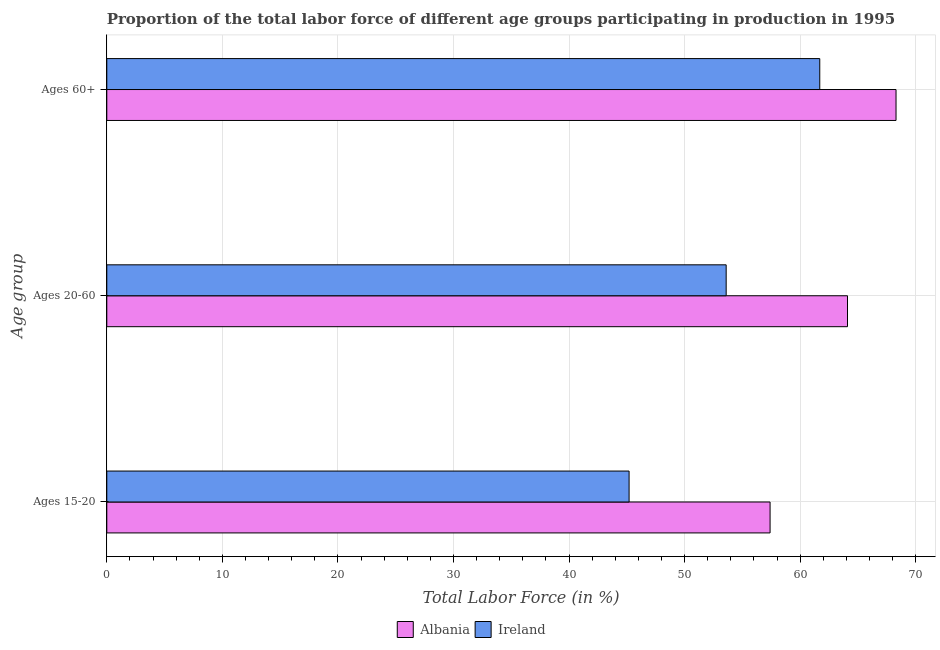How many different coloured bars are there?
Ensure brevity in your answer.  2. How many groups of bars are there?
Ensure brevity in your answer.  3. How many bars are there on the 2nd tick from the top?
Ensure brevity in your answer.  2. What is the label of the 1st group of bars from the top?
Keep it short and to the point. Ages 60+. What is the percentage of labor force above age 60 in Ireland?
Ensure brevity in your answer.  61.7. Across all countries, what is the maximum percentage of labor force within the age group 15-20?
Provide a short and direct response. 57.4. Across all countries, what is the minimum percentage of labor force within the age group 20-60?
Offer a terse response. 53.6. In which country was the percentage of labor force within the age group 15-20 maximum?
Give a very brief answer. Albania. In which country was the percentage of labor force within the age group 20-60 minimum?
Ensure brevity in your answer.  Ireland. What is the total percentage of labor force above age 60 in the graph?
Your answer should be very brief. 130. What is the difference between the percentage of labor force within the age group 15-20 in Ireland and that in Albania?
Ensure brevity in your answer.  -12.2. What is the difference between the percentage of labor force within the age group 15-20 in Ireland and the percentage of labor force above age 60 in Albania?
Ensure brevity in your answer.  -23.1. What is the average percentage of labor force within the age group 15-20 per country?
Your answer should be compact. 51.3. What is the difference between the percentage of labor force within the age group 15-20 and percentage of labor force within the age group 20-60 in Ireland?
Your response must be concise. -8.4. What is the ratio of the percentage of labor force within the age group 20-60 in Albania to that in Ireland?
Offer a very short reply. 1.2. What is the difference between the highest and the second highest percentage of labor force above age 60?
Ensure brevity in your answer.  6.6. What is the difference between the highest and the lowest percentage of labor force above age 60?
Offer a terse response. 6.6. In how many countries, is the percentage of labor force within the age group 20-60 greater than the average percentage of labor force within the age group 20-60 taken over all countries?
Provide a succinct answer. 1. Is the sum of the percentage of labor force within the age group 20-60 in Albania and Ireland greater than the maximum percentage of labor force above age 60 across all countries?
Offer a terse response. Yes. What does the 2nd bar from the top in Ages 15-20 represents?
Offer a terse response. Albania. What does the 1st bar from the bottom in Ages 15-20 represents?
Your answer should be very brief. Albania. How many bars are there?
Your answer should be compact. 6. Are all the bars in the graph horizontal?
Ensure brevity in your answer.  Yes. How many countries are there in the graph?
Ensure brevity in your answer.  2. What is the difference between two consecutive major ticks on the X-axis?
Give a very brief answer. 10. Are the values on the major ticks of X-axis written in scientific E-notation?
Offer a terse response. No. Does the graph contain any zero values?
Offer a terse response. No. Where does the legend appear in the graph?
Ensure brevity in your answer.  Bottom center. How many legend labels are there?
Make the answer very short. 2. How are the legend labels stacked?
Your response must be concise. Horizontal. What is the title of the graph?
Keep it short and to the point. Proportion of the total labor force of different age groups participating in production in 1995. Does "Algeria" appear as one of the legend labels in the graph?
Your response must be concise. No. What is the label or title of the X-axis?
Keep it short and to the point. Total Labor Force (in %). What is the label or title of the Y-axis?
Your answer should be compact. Age group. What is the Total Labor Force (in %) of Albania in Ages 15-20?
Provide a succinct answer. 57.4. What is the Total Labor Force (in %) of Ireland in Ages 15-20?
Make the answer very short. 45.2. What is the Total Labor Force (in %) of Albania in Ages 20-60?
Keep it short and to the point. 64.1. What is the Total Labor Force (in %) in Ireland in Ages 20-60?
Your answer should be compact. 53.6. What is the Total Labor Force (in %) of Albania in Ages 60+?
Keep it short and to the point. 68.3. What is the Total Labor Force (in %) of Ireland in Ages 60+?
Keep it short and to the point. 61.7. Across all Age group, what is the maximum Total Labor Force (in %) in Albania?
Your answer should be compact. 68.3. Across all Age group, what is the maximum Total Labor Force (in %) in Ireland?
Your answer should be compact. 61.7. Across all Age group, what is the minimum Total Labor Force (in %) in Albania?
Give a very brief answer. 57.4. Across all Age group, what is the minimum Total Labor Force (in %) of Ireland?
Provide a succinct answer. 45.2. What is the total Total Labor Force (in %) in Albania in the graph?
Offer a very short reply. 189.8. What is the total Total Labor Force (in %) in Ireland in the graph?
Provide a short and direct response. 160.5. What is the difference between the Total Labor Force (in %) in Ireland in Ages 15-20 and that in Ages 20-60?
Ensure brevity in your answer.  -8.4. What is the difference between the Total Labor Force (in %) in Ireland in Ages 15-20 and that in Ages 60+?
Provide a succinct answer. -16.5. What is the difference between the Total Labor Force (in %) of Albania in Ages 20-60 and that in Ages 60+?
Provide a succinct answer. -4.2. What is the difference between the Total Labor Force (in %) of Albania in Ages 15-20 and the Total Labor Force (in %) of Ireland in Ages 20-60?
Give a very brief answer. 3.8. What is the average Total Labor Force (in %) of Albania per Age group?
Your response must be concise. 63.27. What is the average Total Labor Force (in %) of Ireland per Age group?
Offer a very short reply. 53.5. What is the difference between the Total Labor Force (in %) of Albania and Total Labor Force (in %) of Ireland in Ages 60+?
Offer a terse response. 6.6. What is the ratio of the Total Labor Force (in %) in Albania in Ages 15-20 to that in Ages 20-60?
Your answer should be compact. 0.9. What is the ratio of the Total Labor Force (in %) in Ireland in Ages 15-20 to that in Ages 20-60?
Keep it short and to the point. 0.84. What is the ratio of the Total Labor Force (in %) of Albania in Ages 15-20 to that in Ages 60+?
Ensure brevity in your answer.  0.84. What is the ratio of the Total Labor Force (in %) of Ireland in Ages 15-20 to that in Ages 60+?
Ensure brevity in your answer.  0.73. What is the ratio of the Total Labor Force (in %) in Albania in Ages 20-60 to that in Ages 60+?
Your answer should be very brief. 0.94. What is the ratio of the Total Labor Force (in %) of Ireland in Ages 20-60 to that in Ages 60+?
Your answer should be very brief. 0.87. What is the difference between the highest and the second highest Total Labor Force (in %) of Albania?
Your response must be concise. 4.2. 